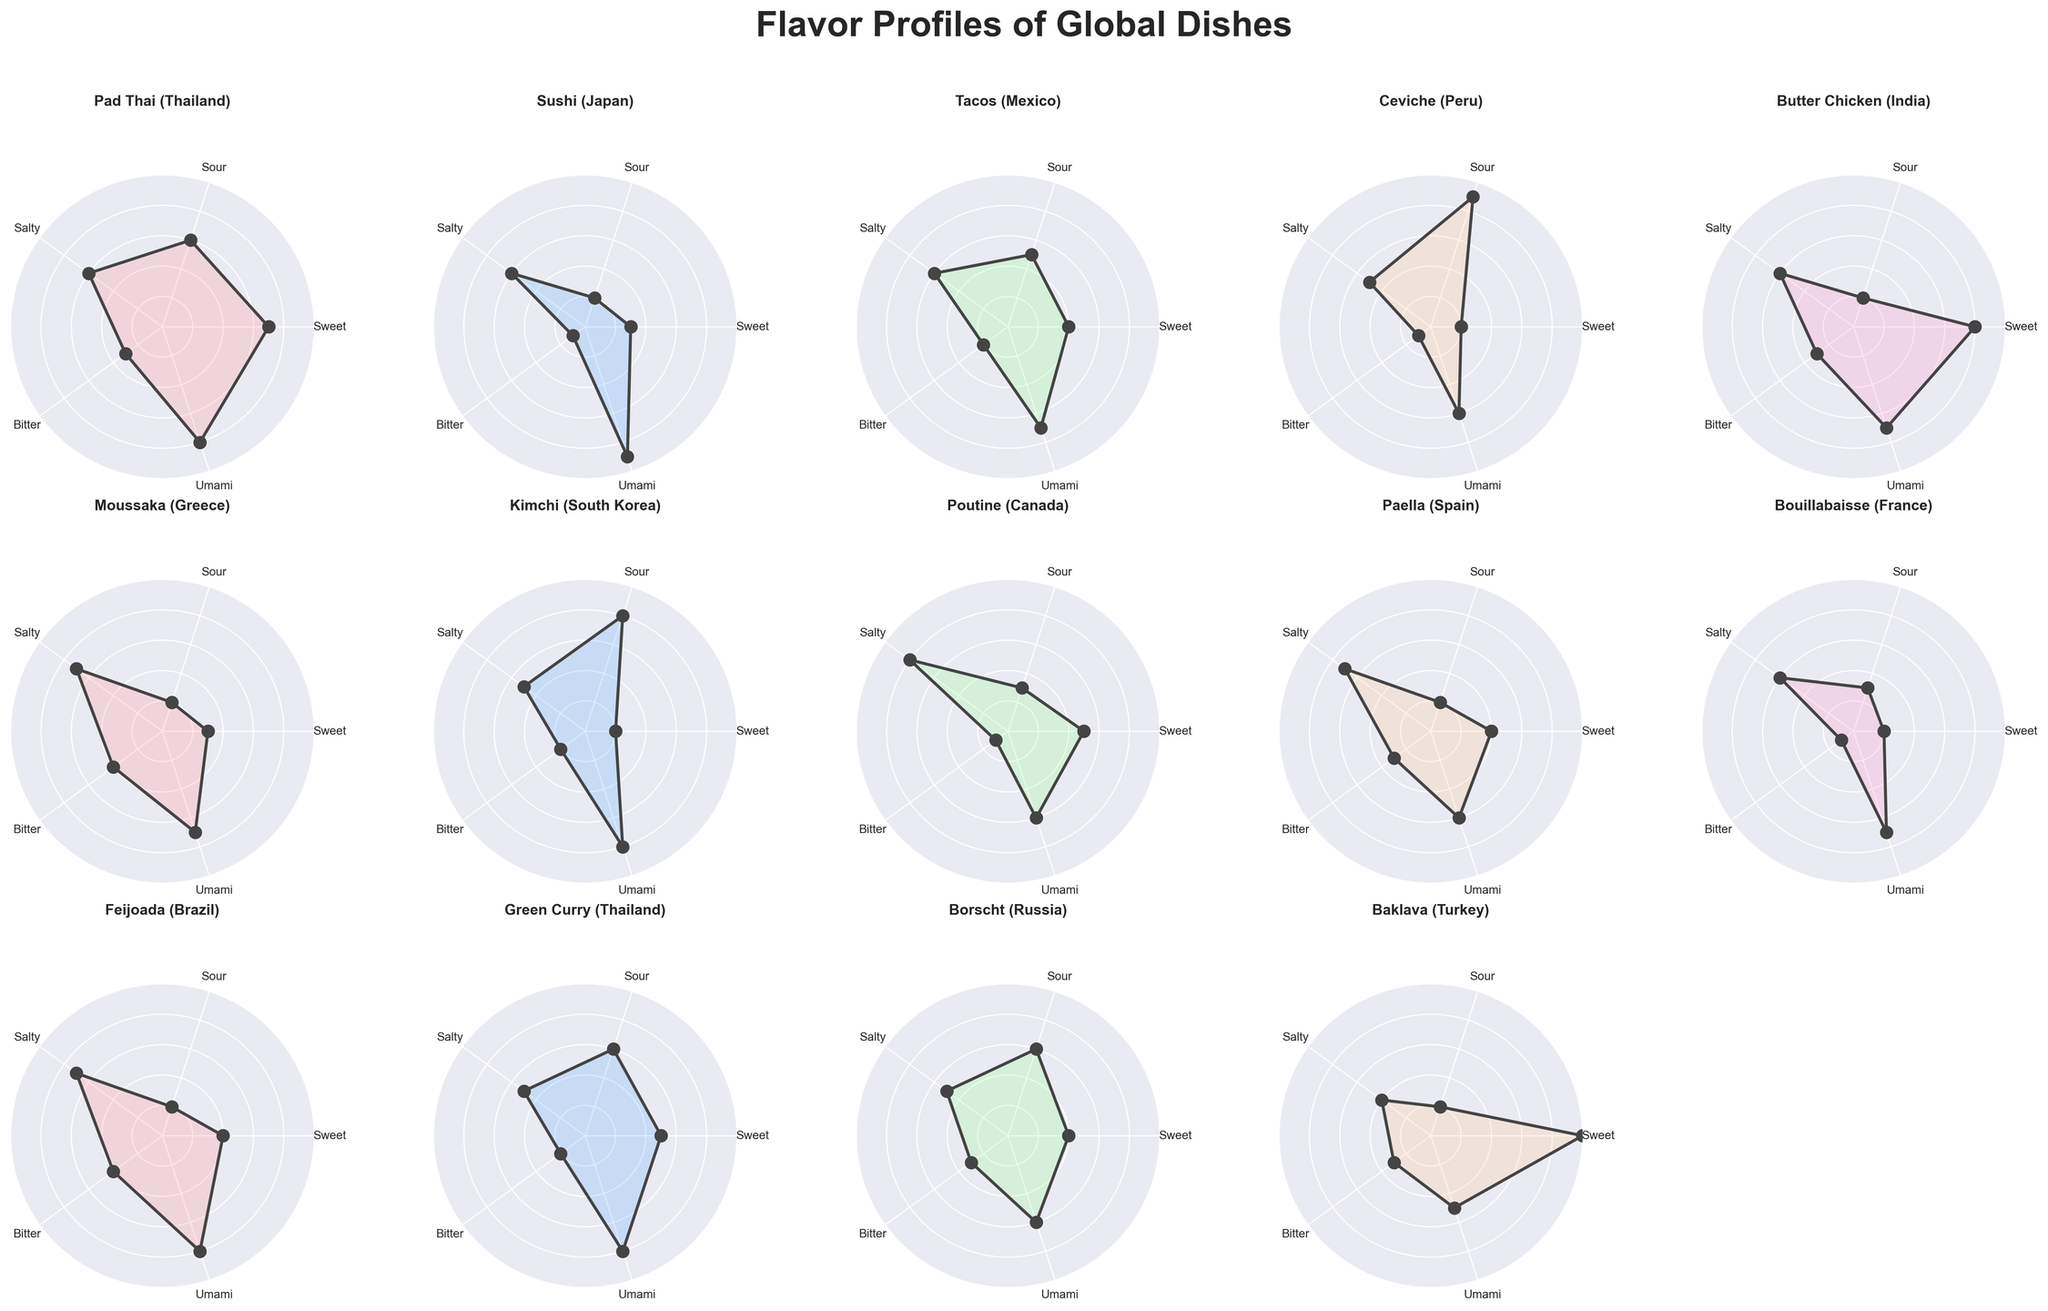Which dish has the highest sour flavor profile? The figure shows a polar chart with various dishes and their flavor profiles. By examining the "sour" axis, Ceviche from Peru has the highest score of 9.
Answer: Ceviche Which dish from Thailand has a higher sweet flavor profile? The figure includes two dishes from Thailand: Pad Thai and Green Curry. Comparing their sweet scores, Pad Thai has a higher score (7) than Green Curry (5).
Answer: Pad Thai Which dishes have an umami score of 8? By looking at the 'Umami' axis across the polar charts, Pad Thai, Sushi, Kimchi, Feijoada, and Green Curry all have an umami score of 8.
Answer: Pad Thai, Sushi, Kimchi, Feijoada, Green Curry What's the difference in the bitter flavor profile between Moussaka and Feijoada? Moussaka has a bitter score of 4, while Feijoada has a bitter score of 4 as well. The difference between their bitter scores is 0.
Answer: 0 How many dishes have a sweet score higher than 5? By examining the sweet axis, Pad Thai, Butter Chicken, and Baklava have scores higher than 5. This gives us a total of 3 dishes.
Answer: 3 Which dish has the most balanced flavor profile (least variation between scores)? To determine the most balanced profile, look for the dish where the flavor scores are closest to each other. Sushi has scores of 3, 2, 6, 1, and 9, with most values being close to the median.
Answer: Sushi Which dish has the highest combination of sweet and salty flavors? Sum the sweet and salty scores for each dish. Pad Thai (7+6=13), Butter Chicken (8+6=14), Baklava (10+4=14). Butter Chicken and Baklava have the highest combined flavor scores.
Answer: Butter Chicken, Baklava Compare the savory (umami) scores of the Japanese and Brazilian dishes. Which is higher? The Japanese dish Sushi has an umami score of 9, and the Brazilian dish Feijoada has a score of 8. Sushi has a higher umami score.
Answer: Sushi Which dish has the lowest salty flavor profile? By examining the salty axis, Baklava from Turkey has the lowest salty score of 4.
Answer: Baklava What is the average bitter flavor score of all dishes? Add all bitter scores and divide by the number of dishes (3+1+2+1+3+4+2+1+3+1+4+2+3+3)=33, Number of dishes=14; The average is 33/14 ≈ 2.36
Answer: 2.36 